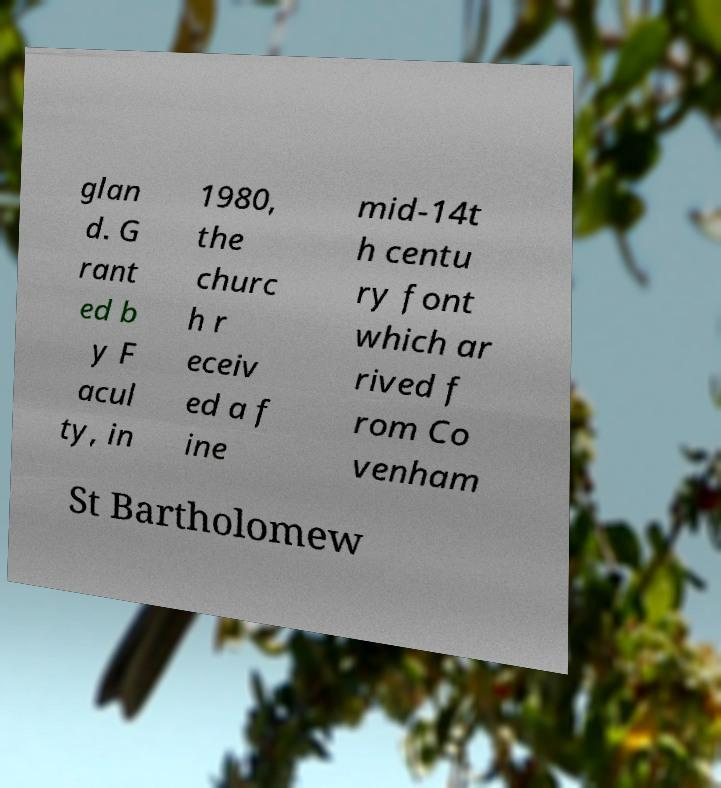I need the written content from this picture converted into text. Can you do that? glan d. G rant ed b y F acul ty, in 1980, the churc h r eceiv ed a f ine mid-14t h centu ry font which ar rived f rom Co venham St Bartholomew 